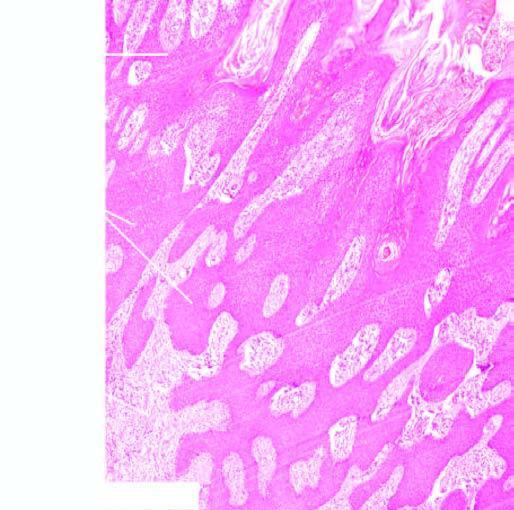does the vesselwall show moderate chronic inflammation?
Answer the question using a single word or phrase. No 